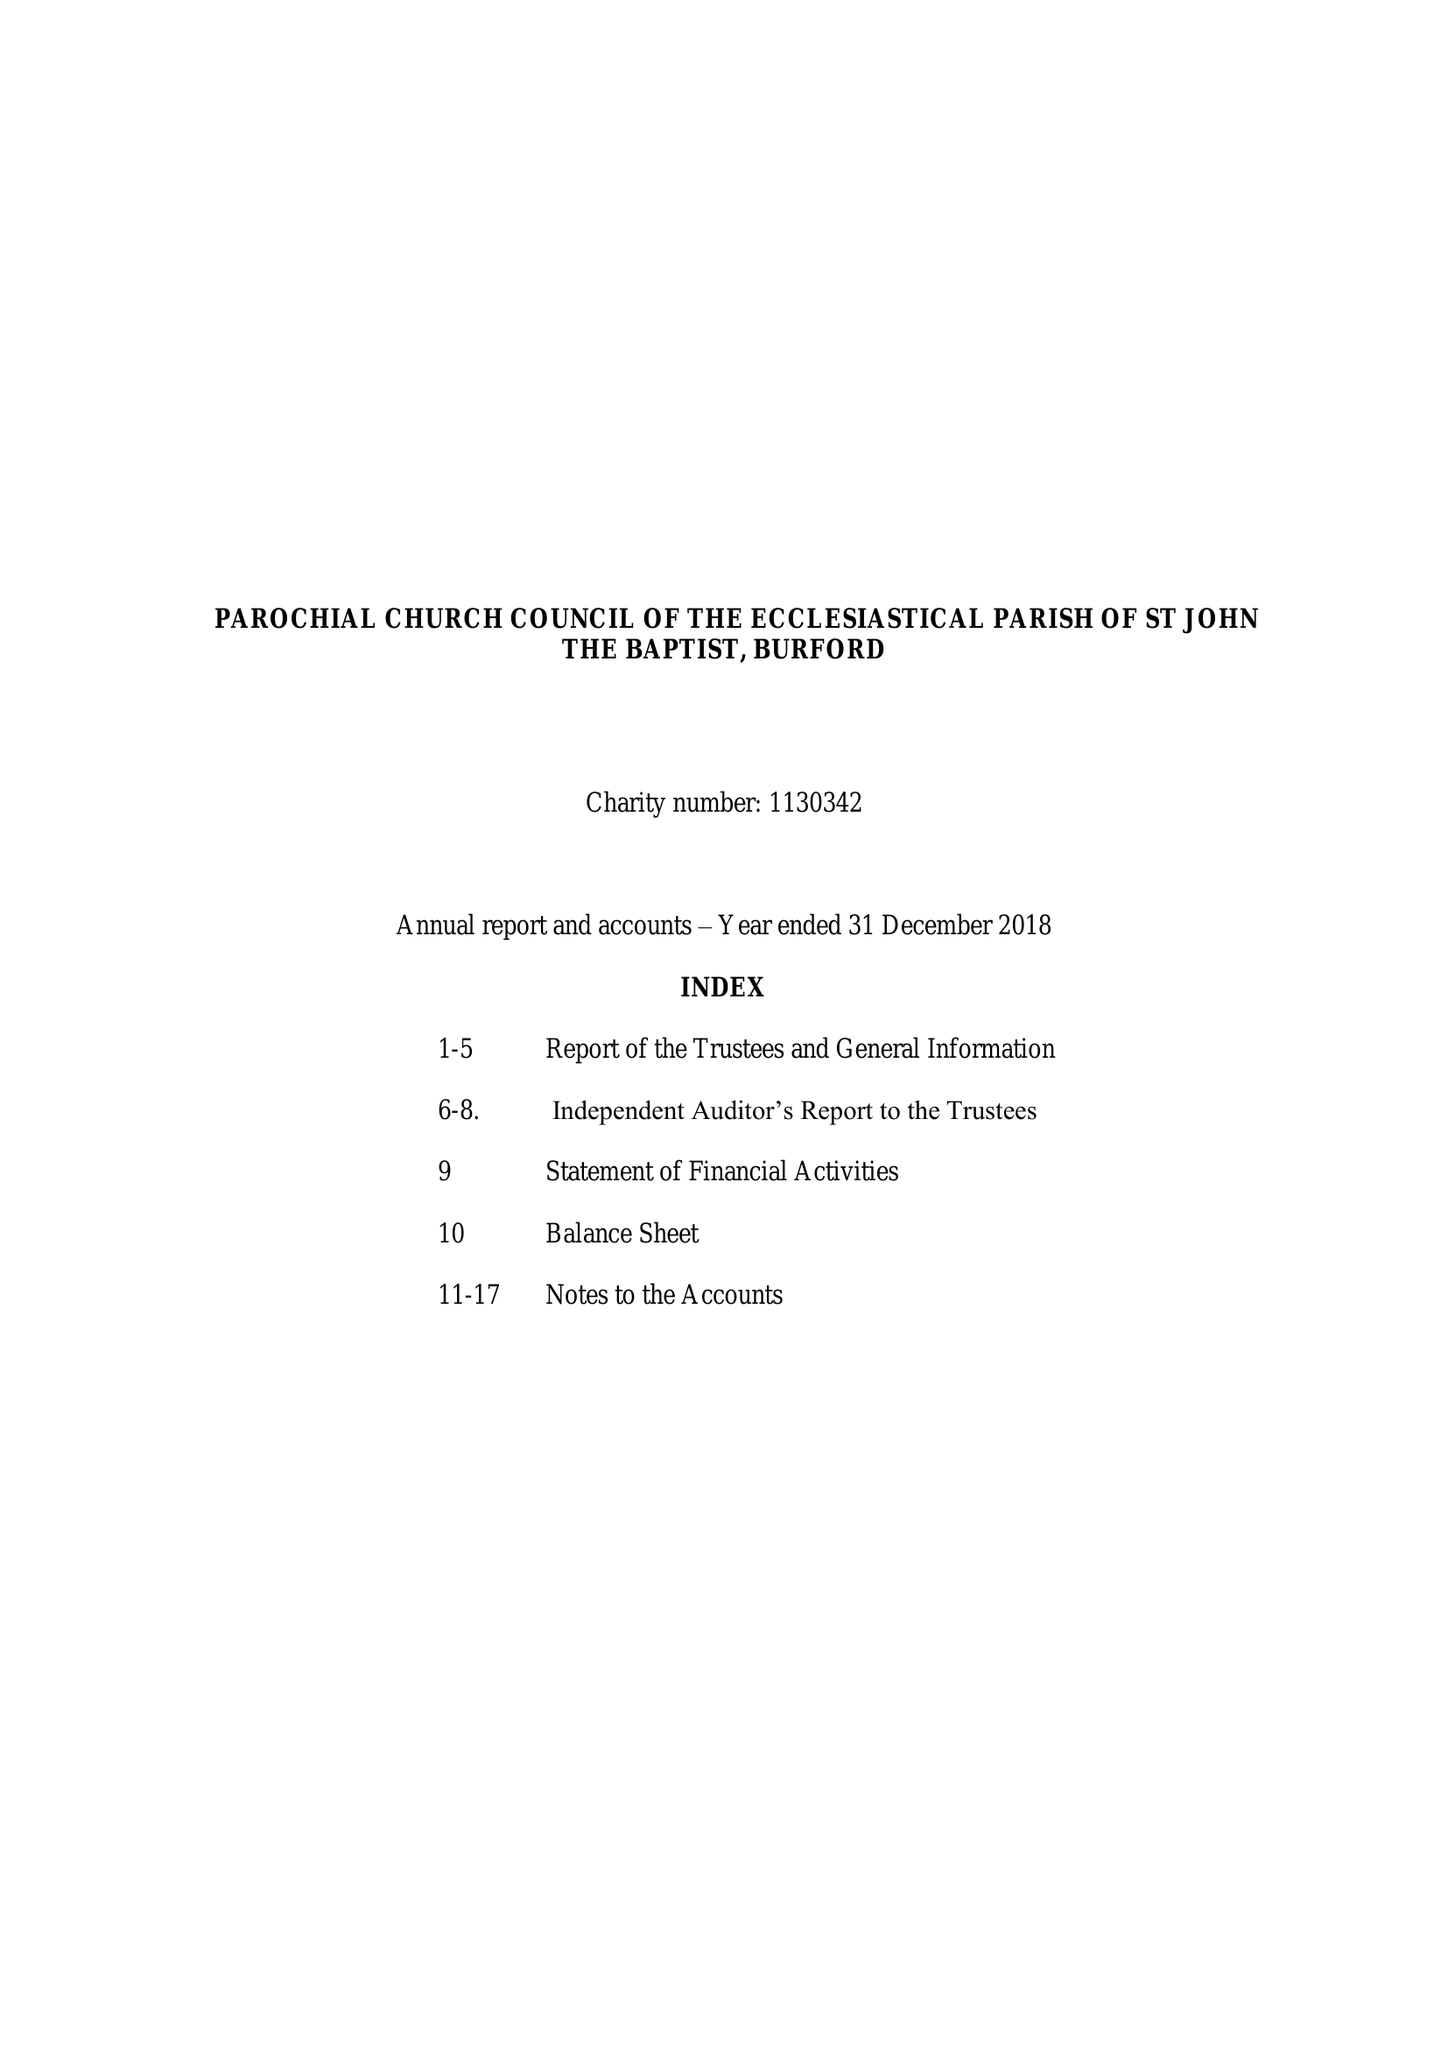What is the value for the report_date?
Answer the question using a single word or phrase. 2018-12-31 